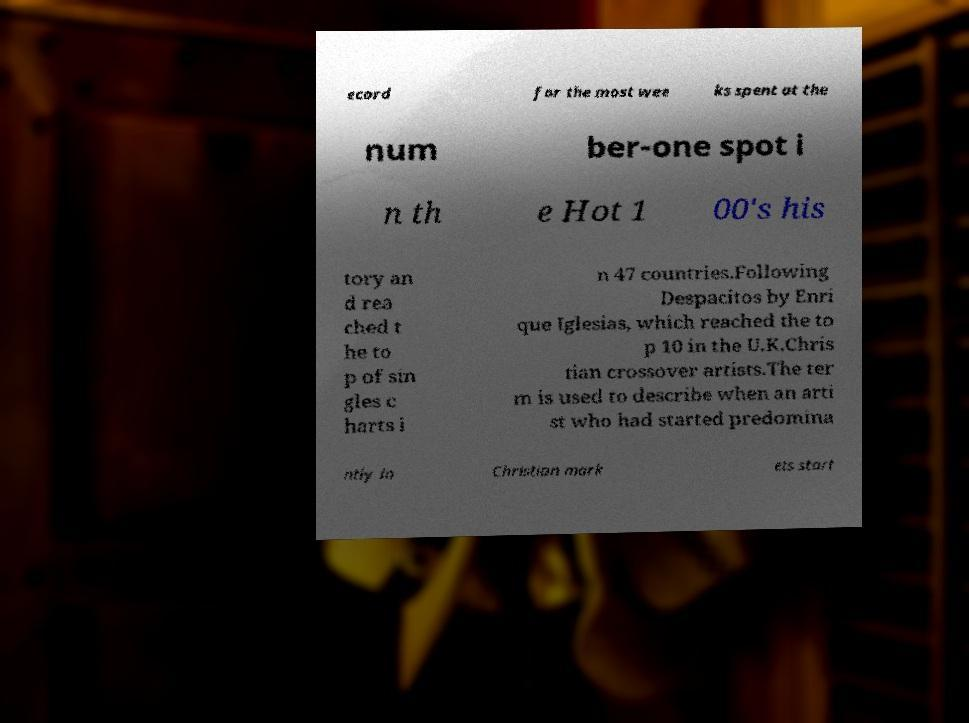Could you extract and type out the text from this image? ecord for the most wee ks spent at the num ber-one spot i n th e Hot 1 00's his tory an d rea ched t he to p of sin gles c harts i n 47 countries.Following Despacitos by Enri que Iglesias, which reached the to p 10 in the U.K.Chris tian crossover artists.The ter m is used to describe when an arti st who had started predomina ntly in Christian mark ets start 